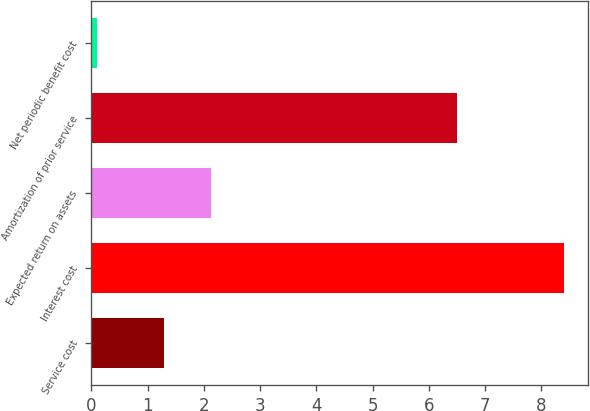Convert chart. <chart><loc_0><loc_0><loc_500><loc_500><bar_chart><fcel>Service cost<fcel>Interest cost<fcel>Expected return on assets<fcel>Amortization of prior service<fcel>Net periodic benefit cost<nl><fcel>1.3<fcel>8.4<fcel>2.13<fcel>6.5<fcel>0.1<nl></chart> 